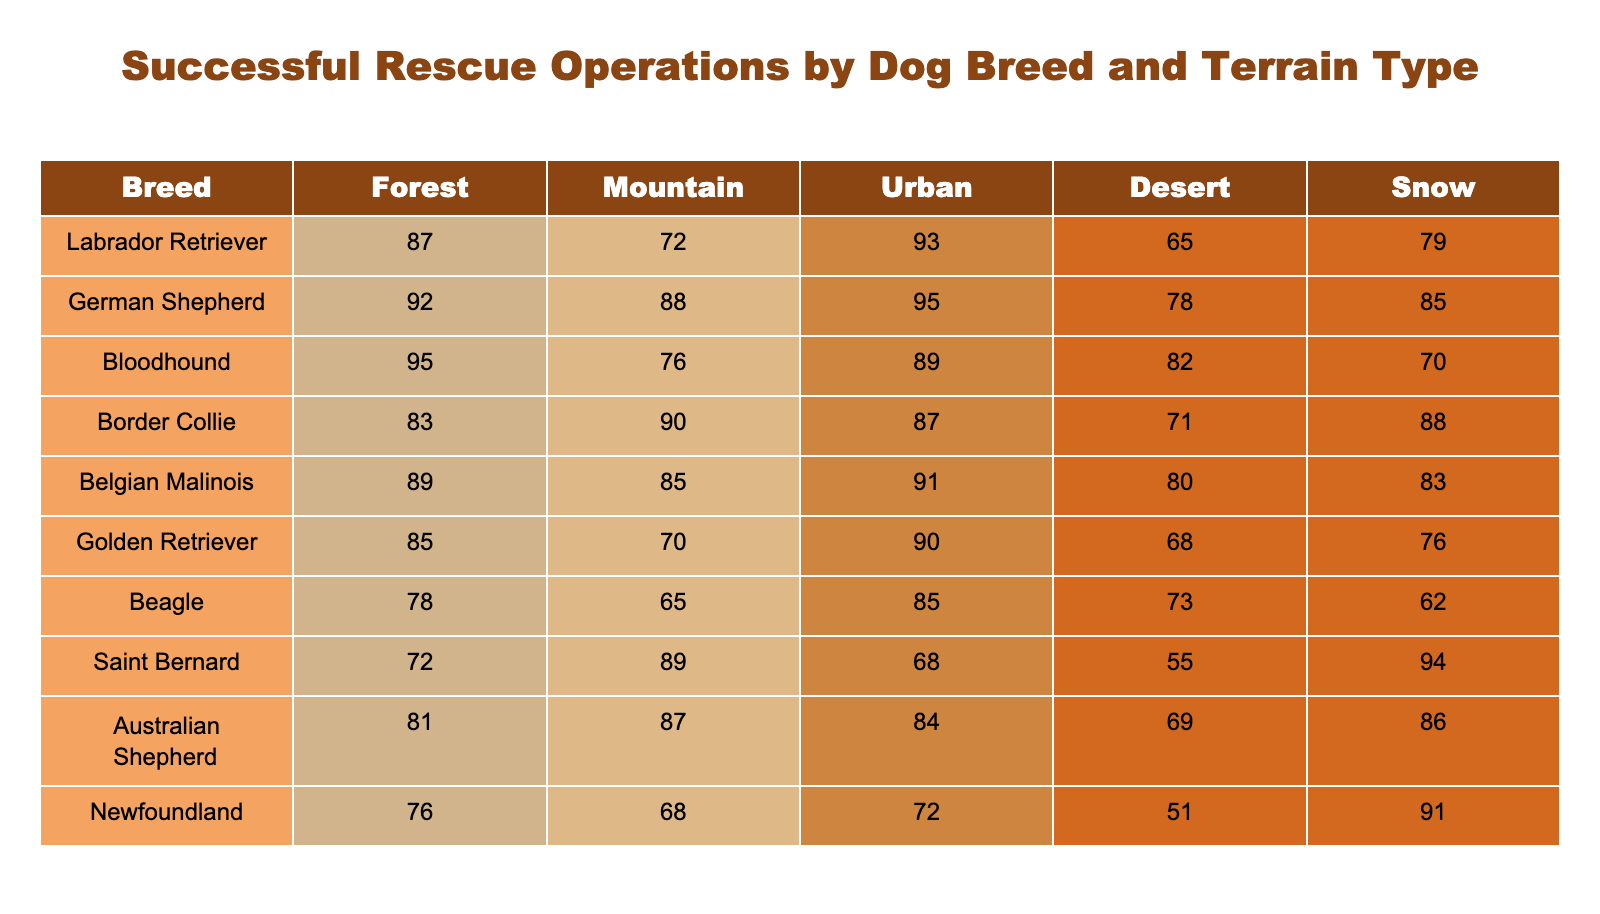What is the highest success rate for the Labrador Retriever in any terrain? The highest success rate for the Labrador Retriever is 93, which occurs in the Urban terrain. This can be found in the respective row for the Labrador Retriever under the Urban column.
Answer: 93 What is the average success rate of German Shepherds across all terrains? To find the average, add the success rates across all terrains for the German Shepherds: (92 + 88 + 95 + 78 + 85) = 438. Then, divide by the number of terrains (5): 438 / 5 = 87.6.
Answer: 87.6 Is the success rate for Bloodhounds higher in Mountains or Snow? The success rates for Bloodhounds are 76 in Mountains and 70 in Snow. Since 76 is greater than 70, the success rate is indeed higher in Mountains.
Answer: Yes Which dog breed has the lowest success rate in Desert terrain? When looking at the Desert column across all breeds, the Saint Bernard has the lowest success rate of 55. This is identified by checking each breed's success rate in the Desert terrain.
Answer: 55 If we combine the success rates of Border Collies in Forest and Snow terrains, what is the total? The Border Collie has a success rate of 83 in the Forest and 88 in the Snow. Adding these two values gives: 83 + 88 = 171.
Answer: 171 Do Golden Retrievers have a better success rate than Beagles in Urban terrain? The Golden Retriever has a success rate of 90, while the Beagle has a success rate of 85 in Urban terrain. Since 90 is greater than 85, it indicates that Golden Retrievers perform better in this area.
Answer: Yes What is the difference in success rates between the best-performing breed in the Mountain terrain and the lowest performing? The best-performing breed in Mountain terrain is the German Shepherd with 88, and the lowest is the Newfoundland with 68. The difference is: 88 - 68 = 20.
Answer: 20 Which breed has the highest success rate in Snow terrain? In the Snow column, the Saint Bernard has the highest success rate of 94. This is determined by comparing all values in the Snow column.
Answer: 94 Which terrain had the most consistently high success rates among breeds, based on visual inspection of the table? By observing the table, the Forest and Mountain terrains exhibit relatively high success rates across most breeds. Analyzing the rows, Forest has several high numbers, indicating consistency.
Answer: Forest and Mountain 